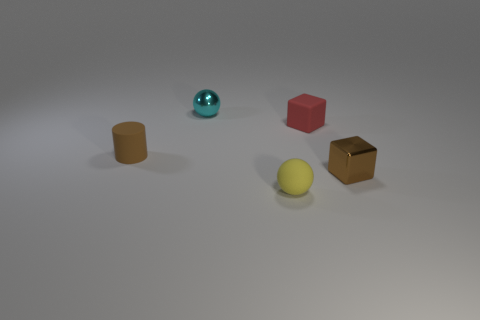Add 1 cyan things. How many objects exist? 6 Subtract all blocks. How many objects are left? 3 Add 4 red cubes. How many red cubes are left? 5 Add 4 tiny red rubber blocks. How many tiny red rubber blocks exist? 5 Subtract 1 brown blocks. How many objects are left? 4 Subtract all small blue objects. Subtract all brown objects. How many objects are left? 3 